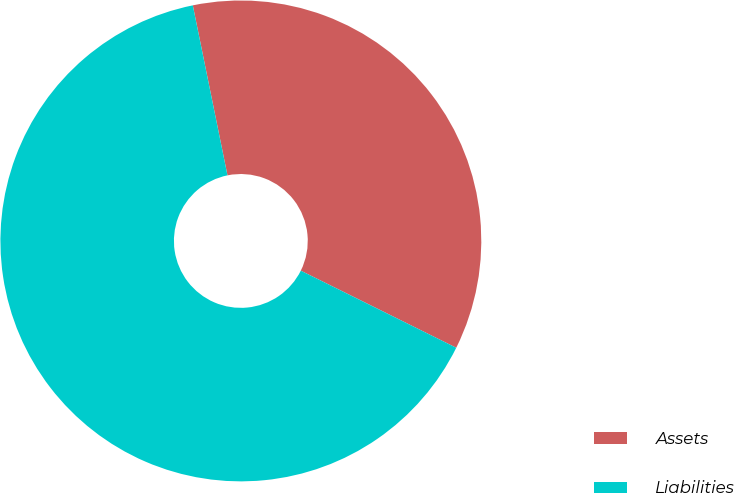<chart> <loc_0><loc_0><loc_500><loc_500><pie_chart><fcel>Assets<fcel>Liabilities<nl><fcel>35.53%<fcel>64.47%<nl></chart> 